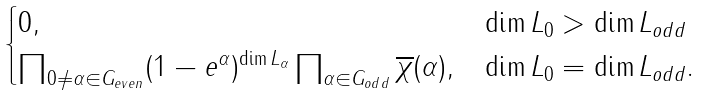Convert formula to latex. <formula><loc_0><loc_0><loc_500><loc_500>\begin{cases} 0 , & \dim L _ { 0 } > \dim L _ { o d d } \\ \prod _ { 0 \ne \alpha \in G _ { e v e n } } ( 1 - e ^ { \alpha } ) ^ { \dim L _ { \alpha } } \prod _ { \alpha \in G _ { o d d } } \overline { \chi } ( \alpha ) , & \dim L _ { 0 } = \dim L _ { o d d } . \end{cases}</formula> 